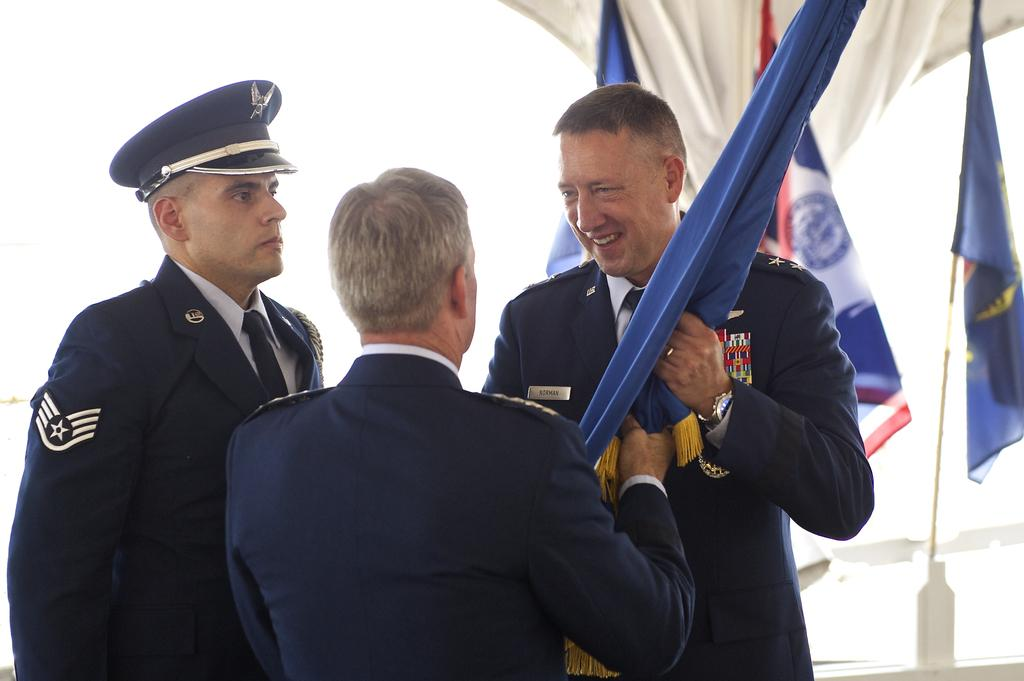How many individuals are present in the image? There are three people in the image. What can be seen besides the people in the image? There are flags in the image. What color is the background of the image? The background of the image is white. What type of belief is expressed in the caption of the image? There is no caption present in the image, so it is not possible to determine any beliefs expressed. 